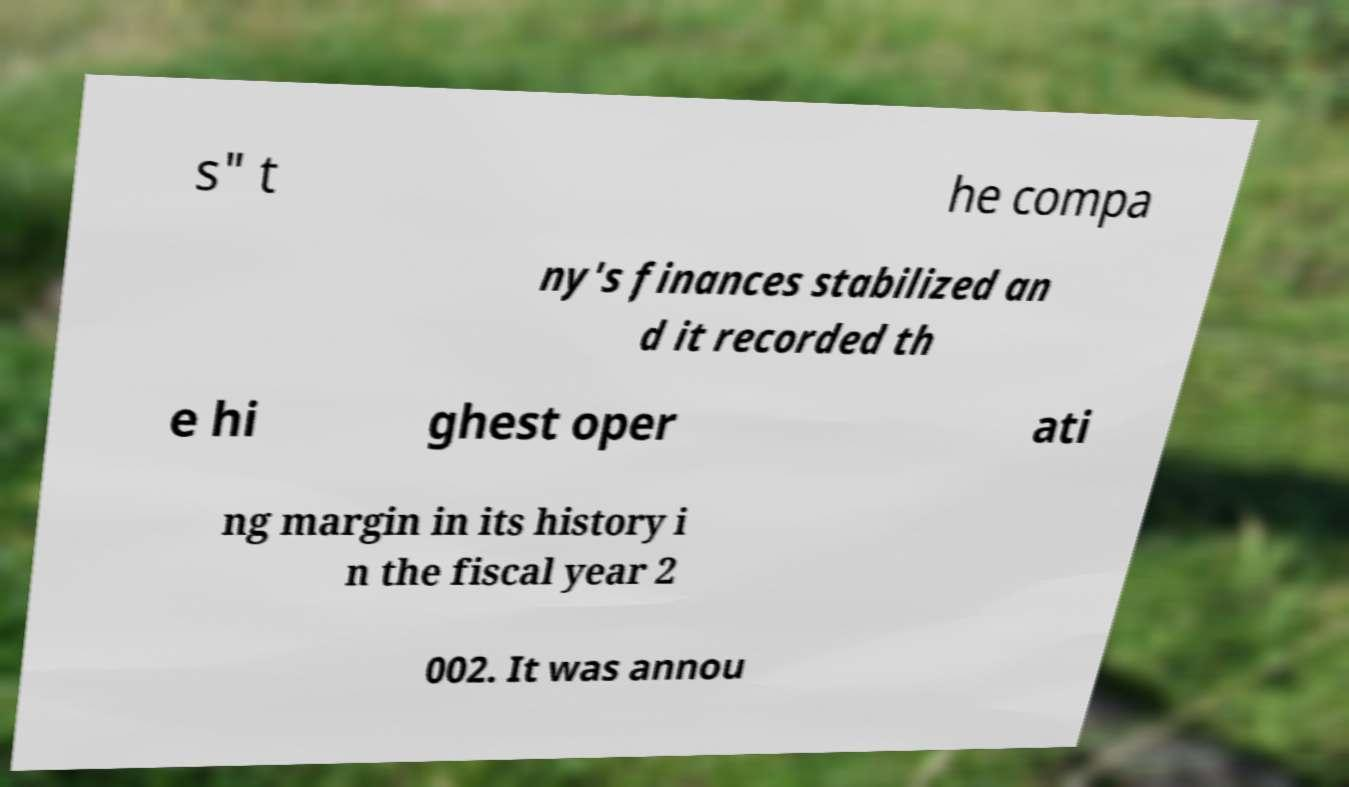What messages or text are displayed in this image? I need them in a readable, typed format. s" t he compa ny's finances stabilized an d it recorded th e hi ghest oper ati ng margin in its history i n the fiscal year 2 002. It was annou 